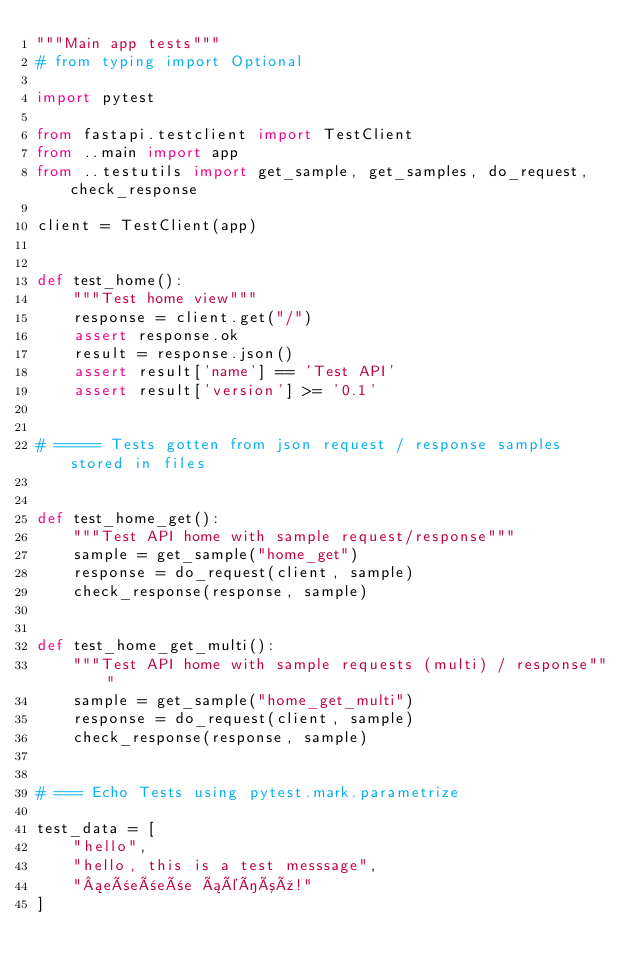<code> <loc_0><loc_0><loc_500><loc_500><_Python_>"""Main app tests"""
# from typing import Optional

import pytest

from fastapi.testclient import TestClient
from ..main import app
from ..testutils import get_sample, get_samples, do_request, check_response

client = TestClient(app)


def test_home():
    """Test home view"""
    response = client.get("/")
    assert response.ok
    result = response.json()
    assert result['name'] == 'Test API'
    assert result['version'] >= '0.1'


# ===== Tests gotten from json request / response samples stored in files


def test_home_get():
    """Test API home with sample request/response"""
    sample = get_sample("home_get")
    response = do_request(client, sample)
    check_response(response, sample)


def test_home_get_multi():
    """Test API home with sample requests (multi) / response"""
    sample = get_sample("home_get_multi")
    response = do_request(client, sample)
    check_response(response, sample)


# === Echo Tests using pytest.mark.parametrize

test_data = [
    "hello",
    "hello, this is a test messsage",
    "¡eñeñeñe áéíóú!"
]

</code> 